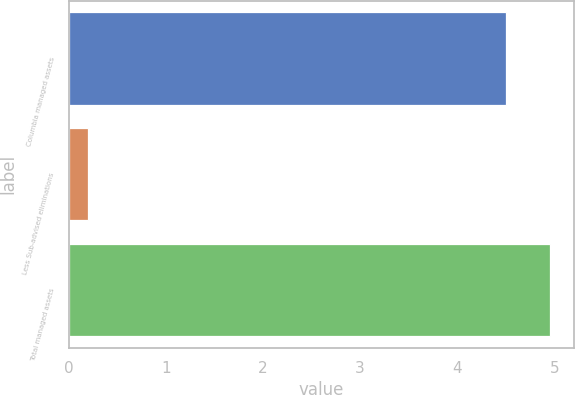<chart> <loc_0><loc_0><loc_500><loc_500><bar_chart><fcel>Columbia managed assets<fcel>Less Sub-advised eliminations<fcel>Total managed assets<nl><fcel>4.5<fcel>0.2<fcel>4.96<nl></chart> 